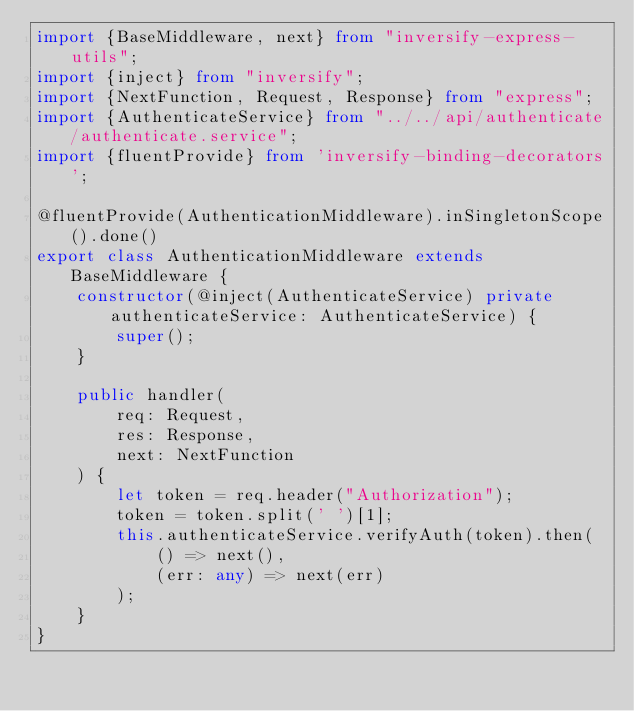Convert code to text. <code><loc_0><loc_0><loc_500><loc_500><_TypeScript_>import {BaseMiddleware, next} from "inversify-express-utils";
import {inject} from "inversify";
import {NextFunction, Request, Response} from "express";
import {AuthenticateService} from "../../api/authenticate/authenticate.service";
import {fluentProvide} from 'inversify-binding-decorators';

@fluentProvide(AuthenticationMiddleware).inSingletonScope().done()
export class AuthenticationMiddleware extends BaseMiddleware {
    constructor(@inject(AuthenticateService) private authenticateService: AuthenticateService) {
        super();
    }

    public handler(
        req: Request,
        res: Response,
        next: NextFunction
    ) {
        let token = req.header("Authorization");
        token = token.split(' ')[1];
        this.authenticateService.verifyAuth(token).then(
            () => next(),
            (err: any) => next(err)
        );
    }
}</code> 